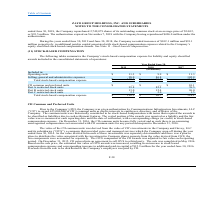According to Zayo Group Holdings's financial document, When did the CII common units become fully vested? According to the financial document, December 31, 2016. The relevant text states: "r credit) to stock-based compensation expense. On December 31, 2016, the CII common units became fully vested and as such there is no remaining unrecognized compensati r credit) to stock-based compens..." Also, How many of CII's common units were awarded as profit interests to employees, directors and affiliates of the company? According to the financial document, 625,000,000. The relevant text states: "(“CII”) to award 625,000,000 of CII’s common units as profits interests to employees, directors, and affiliates of the Company...." Also, What does the following table summarize? The following tables summarize the Company’s stock-based compensation expense for liability and equity classified awards included in the consolidated statements of operations:. The document states: "The following tables summarize the Company’s stock-based compensation expense for liability and equity classified awards included in the consolidated ..." Additionally, Which of the years saw a total stock-based compensation expense of more than 100 million? The document shows two values: 2017 and 2019. From the document: "2019 2018 2017 2019 2018 2017..." Additionally, Which of the years had the highest selling, general and administrative expenses? According to the financial document, 2017. The relevant text states: "2019 2018 2017..." Also, can you calculate: What were the total operating costs for all 3 years? Based on the calculation: 11.3 + 9.9 + 11.3, the result is 32.5 (in millions). This is based on the information: "Operating costs $ 11.3 $ 9.9 $ 11.3 Operating costs $ 11.3 $ 9.9 $ 11.3..." The key data points involved are: 11.3, 9.9. 